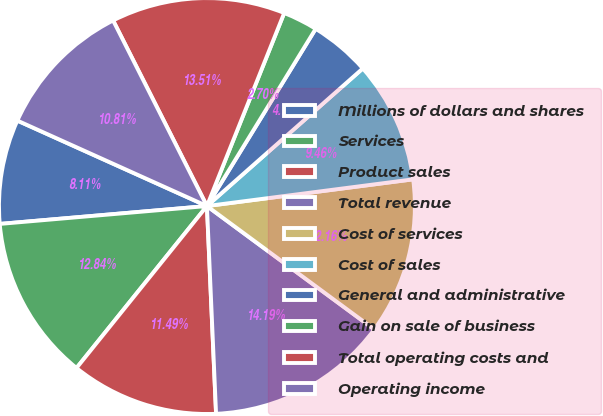Convert chart to OTSL. <chart><loc_0><loc_0><loc_500><loc_500><pie_chart><fcel>Millions of dollars and shares<fcel>Services<fcel>Product sales<fcel>Total revenue<fcel>Cost of services<fcel>Cost of sales<fcel>General and administrative<fcel>Gain on sale of business<fcel>Total operating costs and<fcel>Operating income<nl><fcel>8.11%<fcel>12.84%<fcel>11.49%<fcel>14.19%<fcel>12.16%<fcel>9.46%<fcel>4.73%<fcel>2.7%<fcel>13.51%<fcel>10.81%<nl></chart> 